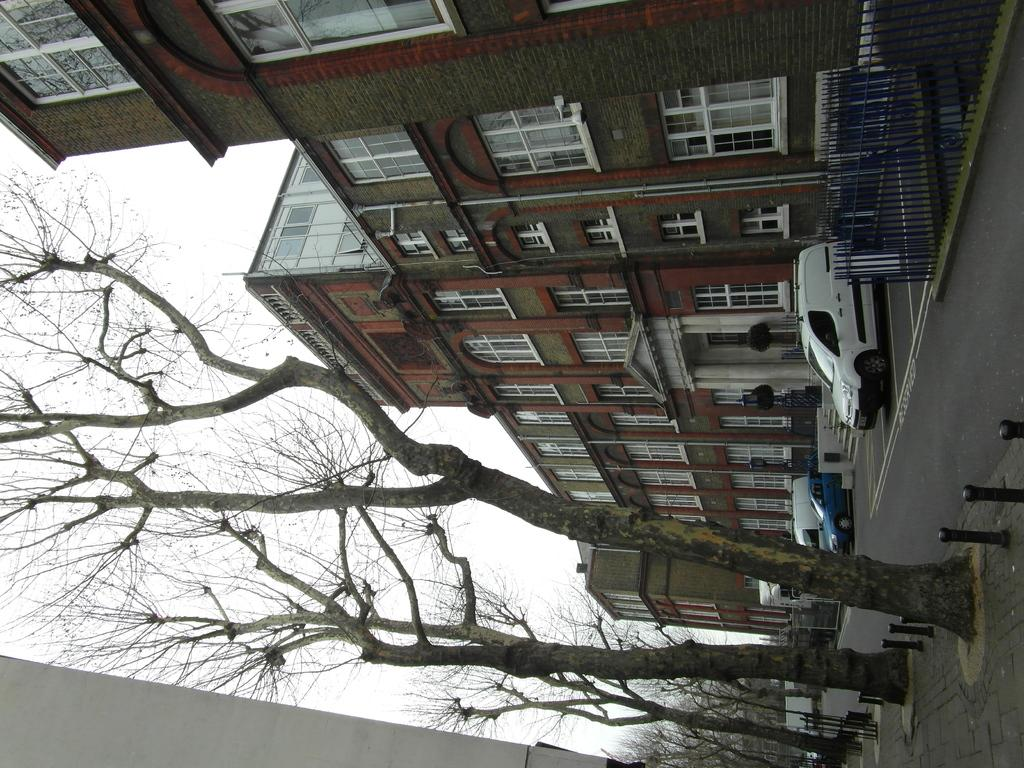What type of structures can be seen in the image? There are buildings in the image. What feature is present that might be used for safety or support? There is a railing in the image. What mode of transportation can be seen in the image? There are vehicles in the image. What type of vegetation is present in the image? There are plants and trees in the image. What type of surface is visible for walking or driving? There are roads and a pavement in the image. What can be seen in the background of the image? The sky is visible in the background of the image. What type of dress is the tree wearing in the image? Trees do not wear dresses; they are plants. What type of body is visible in the image? There are no human or animal bodies present in the image; it features buildings, vehicles, plants, and other inanimate objects. 